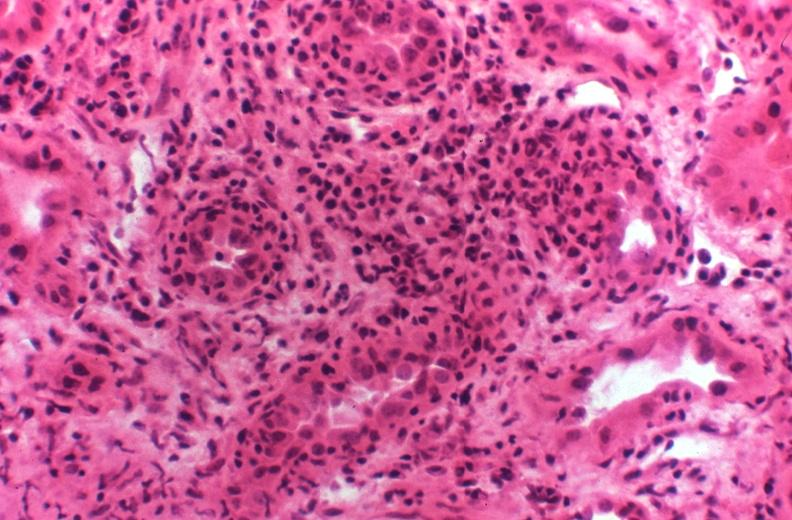what does this image show?
Answer the question using a single word or phrase. Kidney transplant rejection 